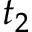Convert formula to latex. <formula><loc_0><loc_0><loc_500><loc_500>t _ { 2 }</formula> 